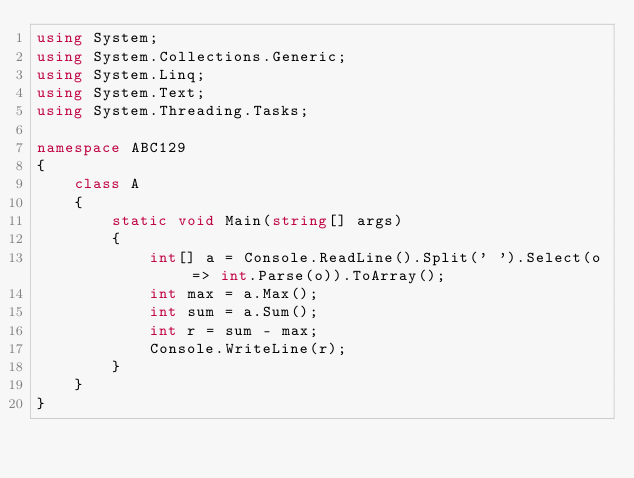Convert code to text. <code><loc_0><loc_0><loc_500><loc_500><_C#_>using System;
using System.Collections.Generic;
using System.Linq;
using System.Text;
using System.Threading.Tasks;

namespace ABC129
{
    class A
    {
        static void Main(string[] args)
        {
            int[] a = Console.ReadLine().Split(' ').Select(o => int.Parse(o)).ToArray();
            int max = a.Max();
            int sum = a.Sum();
            int r = sum - max;
            Console.WriteLine(r);
        }
    }
}
</code> 